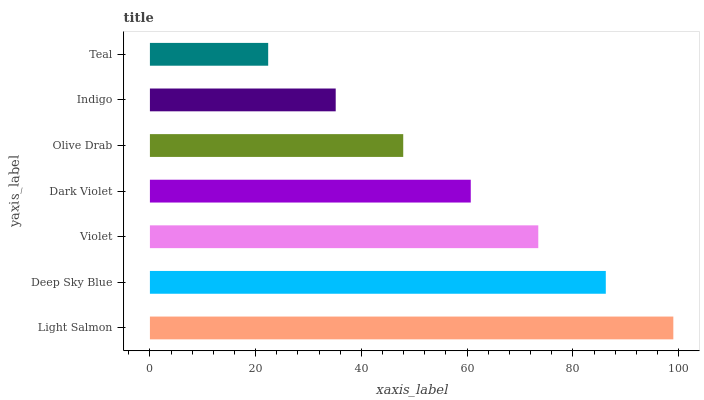Is Teal the minimum?
Answer yes or no. Yes. Is Light Salmon the maximum?
Answer yes or no. Yes. Is Deep Sky Blue the minimum?
Answer yes or no. No. Is Deep Sky Blue the maximum?
Answer yes or no. No. Is Light Salmon greater than Deep Sky Blue?
Answer yes or no. Yes. Is Deep Sky Blue less than Light Salmon?
Answer yes or no. Yes. Is Deep Sky Blue greater than Light Salmon?
Answer yes or no. No. Is Light Salmon less than Deep Sky Blue?
Answer yes or no. No. Is Dark Violet the high median?
Answer yes or no. Yes. Is Dark Violet the low median?
Answer yes or no. Yes. Is Indigo the high median?
Answer yes or no. No. Is Light Salmon the low median?
Answer yes or no. No. 